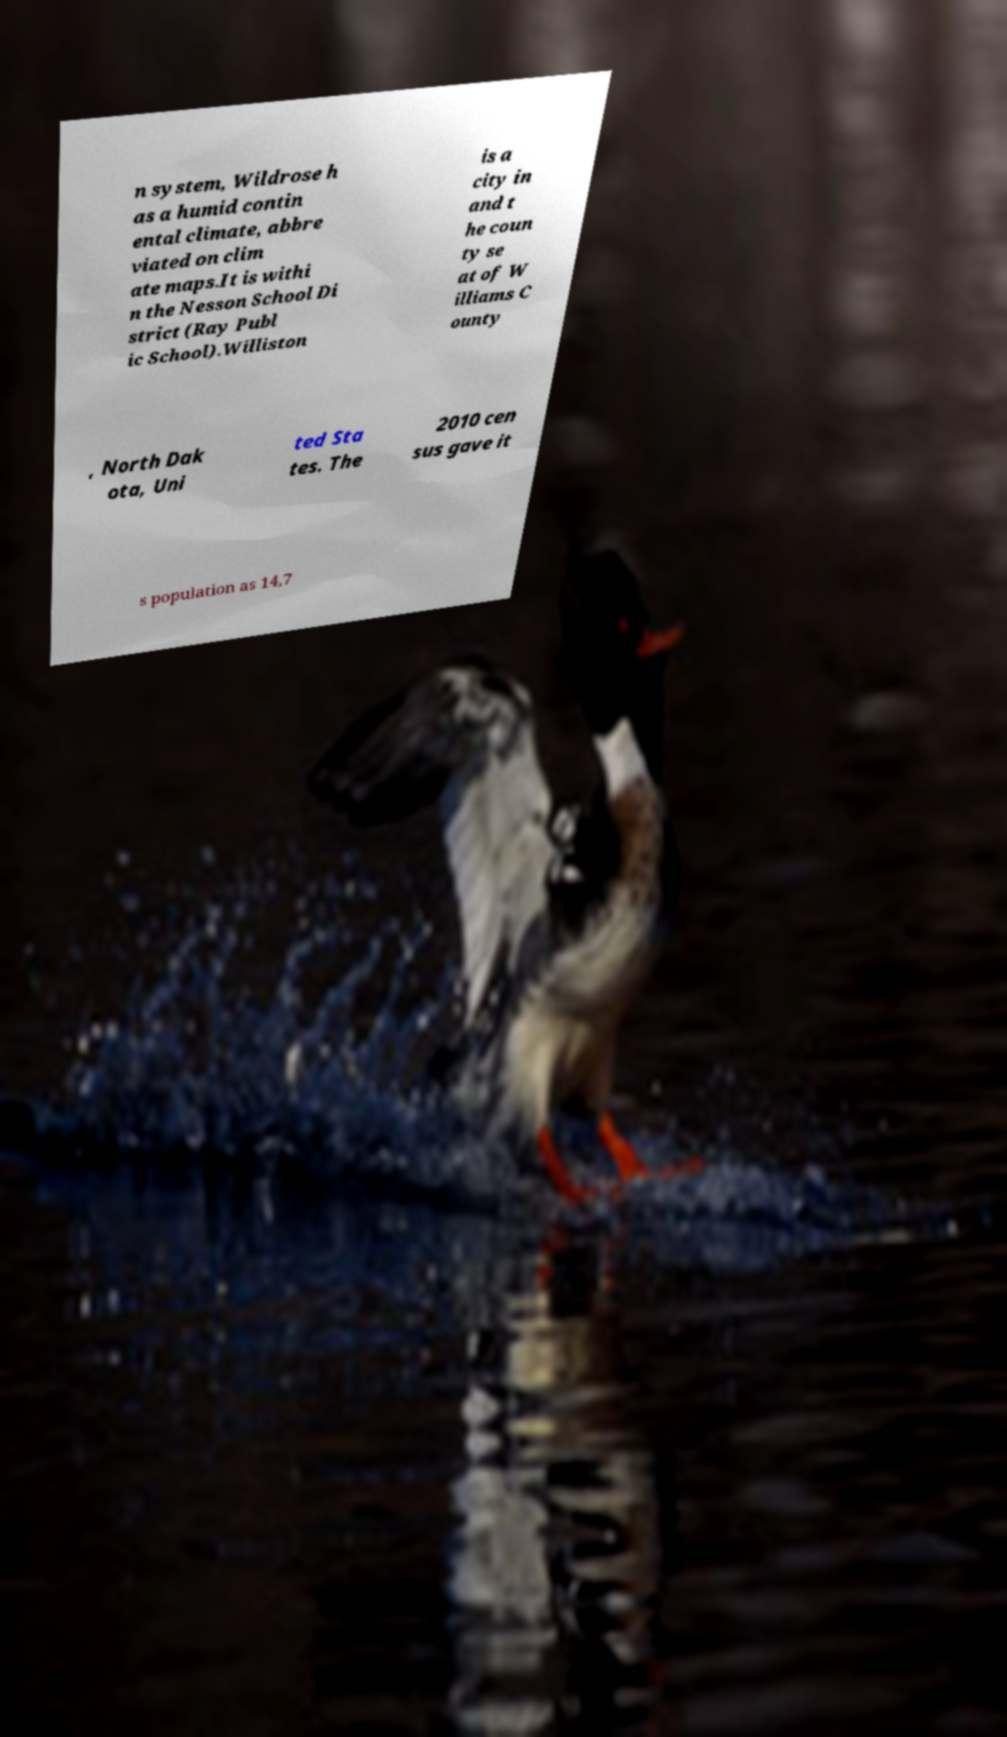There's text embedded in this image that I need extracted. Can you transcribe it verbatim? n system, Wildrose h as a humid contin ental climate, abbre viated on clim ate maps.It is withi n the Nesson School Di strict (Ray Publ ic School).Williston is a city in and t he coun ty se at of W illiams C ounty , North Dak ota, Uni ted Sta tes. The 2010 cen sus gave it s population as 14,7 